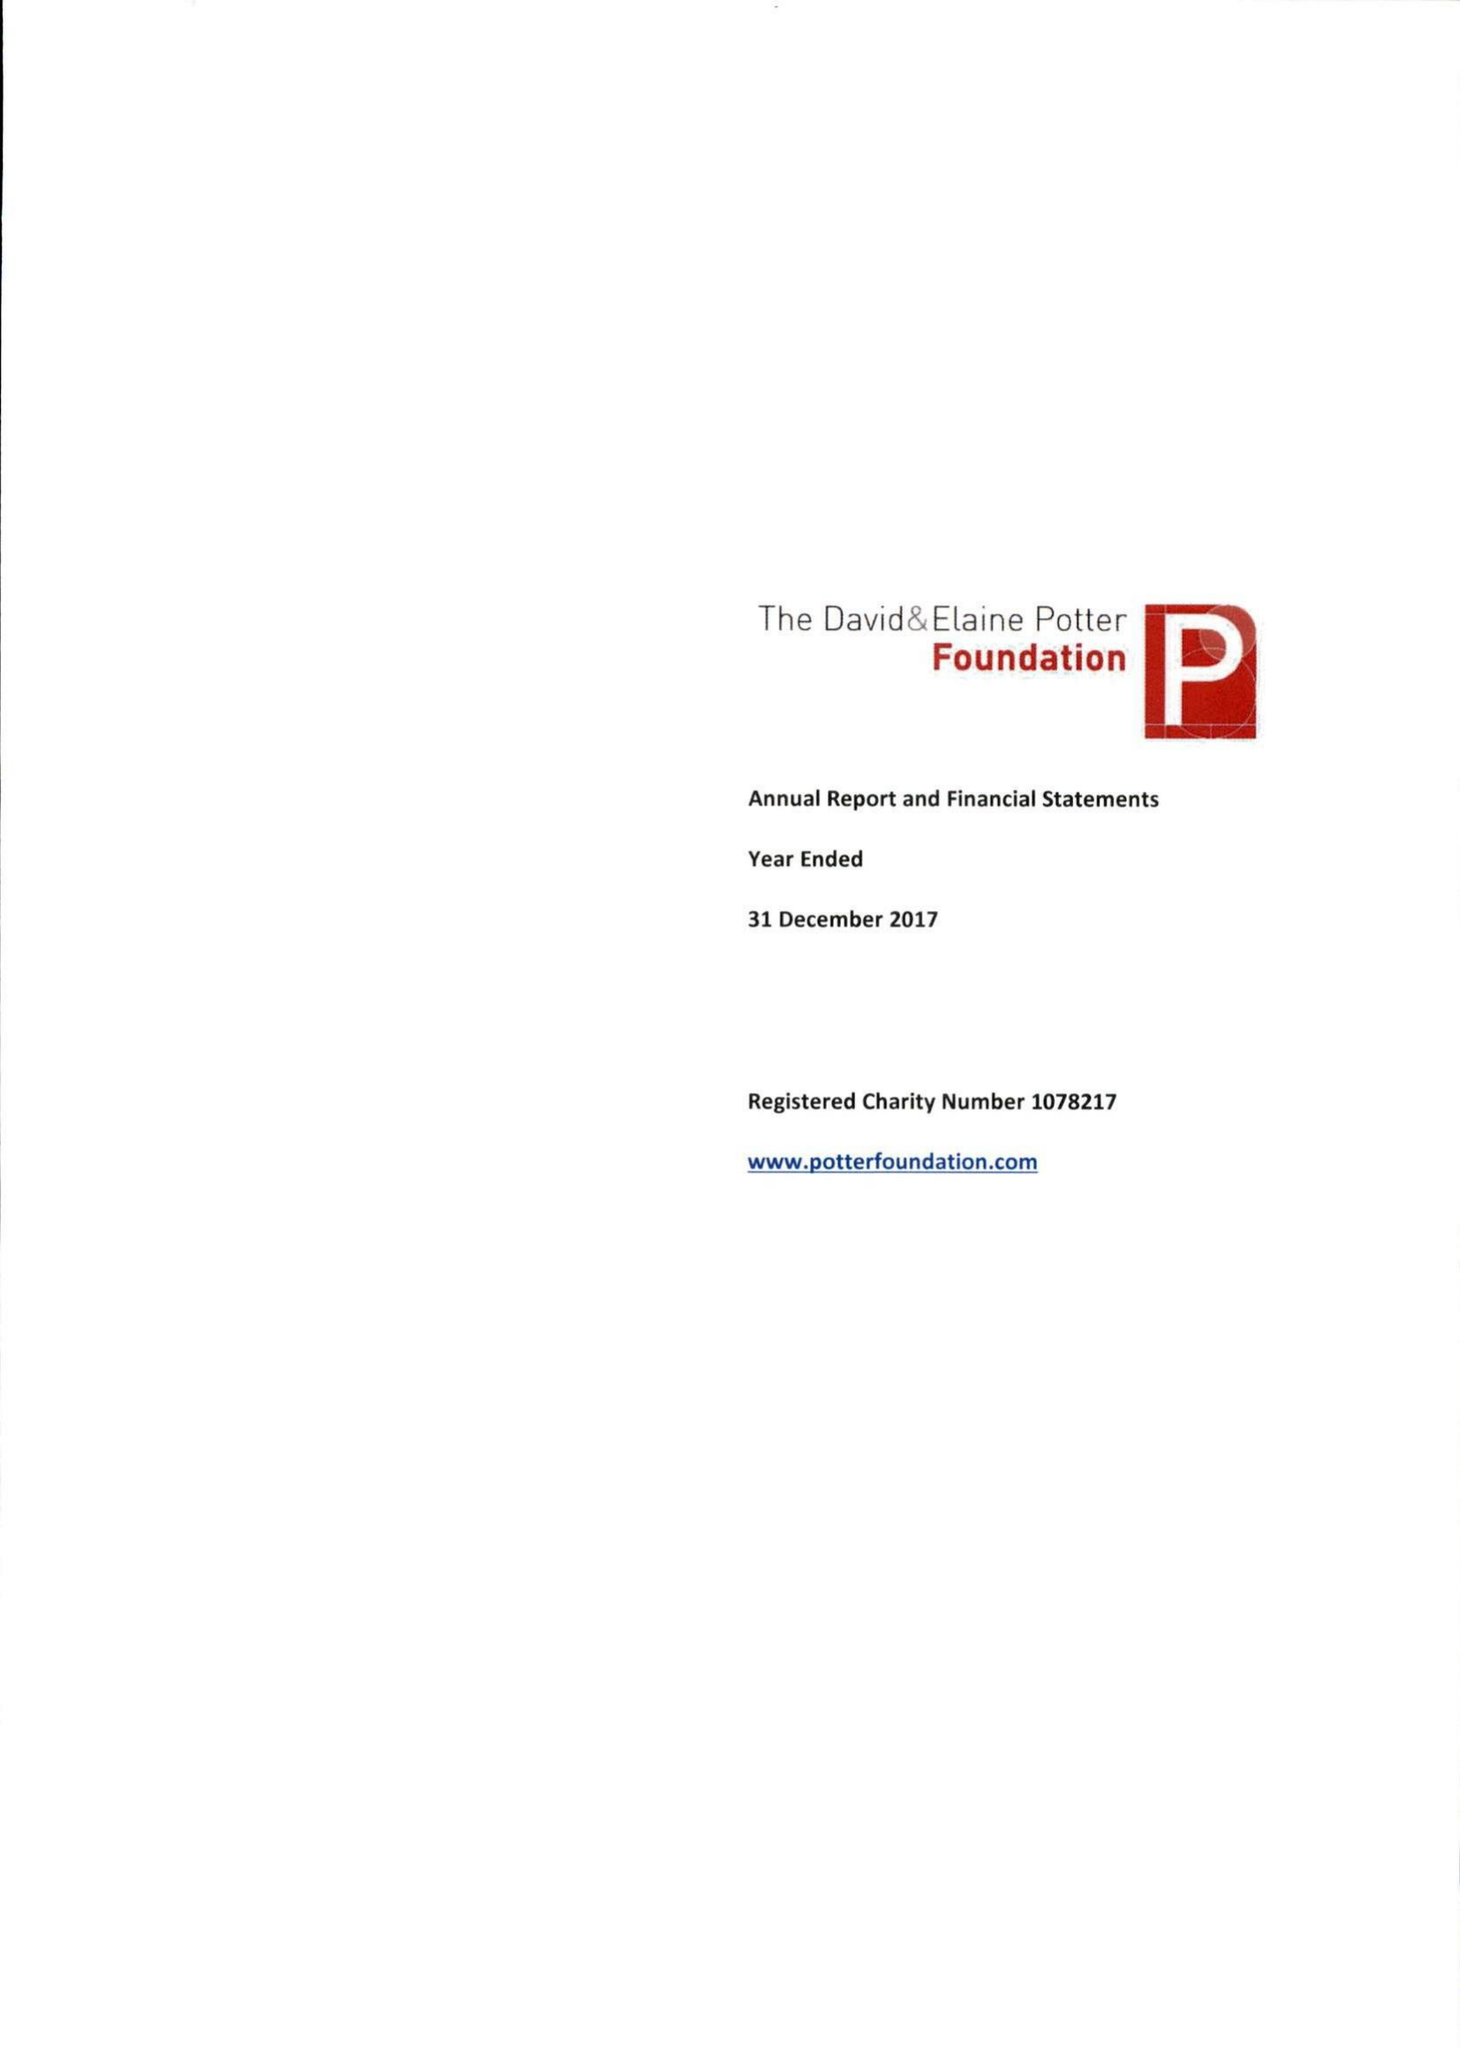What is the value for the report_date?
Answer the question using a single word or phrase. 2017-12-31 